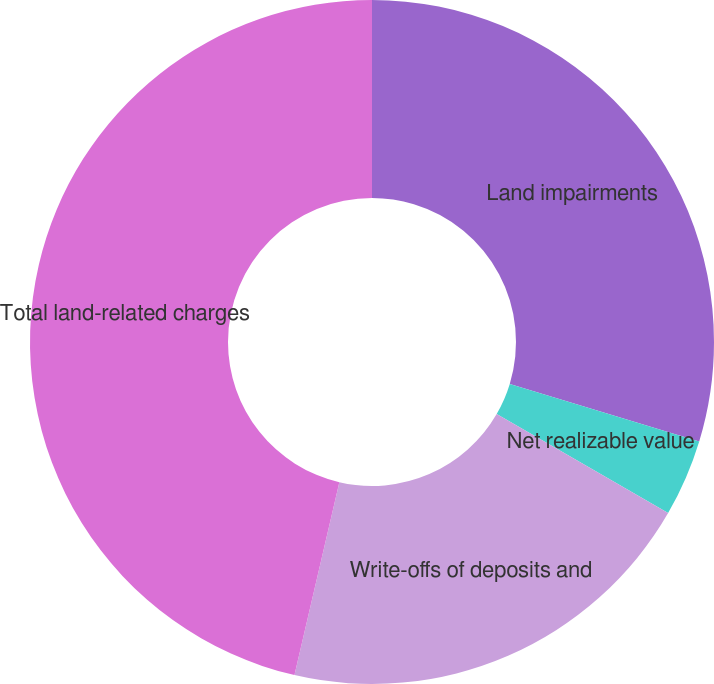Convert chart to OTSL. <chart><loc_0><loc_0><loc_500><loc_500><pie_chart><fcel>Land impairments<fcel>Net realizable value<fcel>Write-offs of deposits and<fcel>Total land-related charges<nl><fcel>29.7%<fcel>3.64%<fcel>20.3%<fcel>46.36%<nl></chart> 